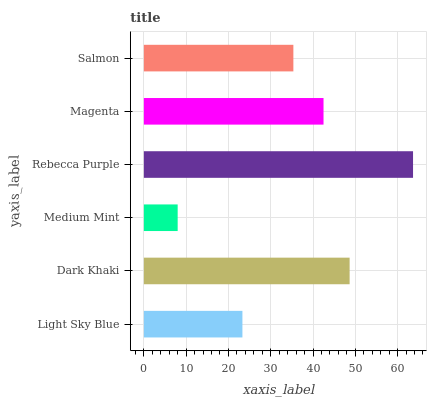Is Medium Mint the minimum?
Answer yes or no. Yes. Is Rebecca Purple the maximum?
Answer yes or no. Yes. Is Dark Khaki the minimum?
Answer yes or no. No. Is Dark Khaki the maximum?
Answer yes or no. No. Is Dark Khaki greater than Light Sky Blue?
Answer yes or no. Yes. Is Light Sky Blue less than Dark Khaki?
Answer yes or no. Yes. Is Light Sky Blue greater than Dark Khaki?
Answer yes or no. No. Is Dark Khaki less than Light Sky Blue?
Answer yes or no. No. Is Magenta the high median?
Answer yes or no. Yes. Is Salmon the low median?
Answer yes or no. Yes. Is Dark Khaki the high median?
Answer yes or no. No. Is Rebecca Purple the low median?
Answer yes or no. No. 